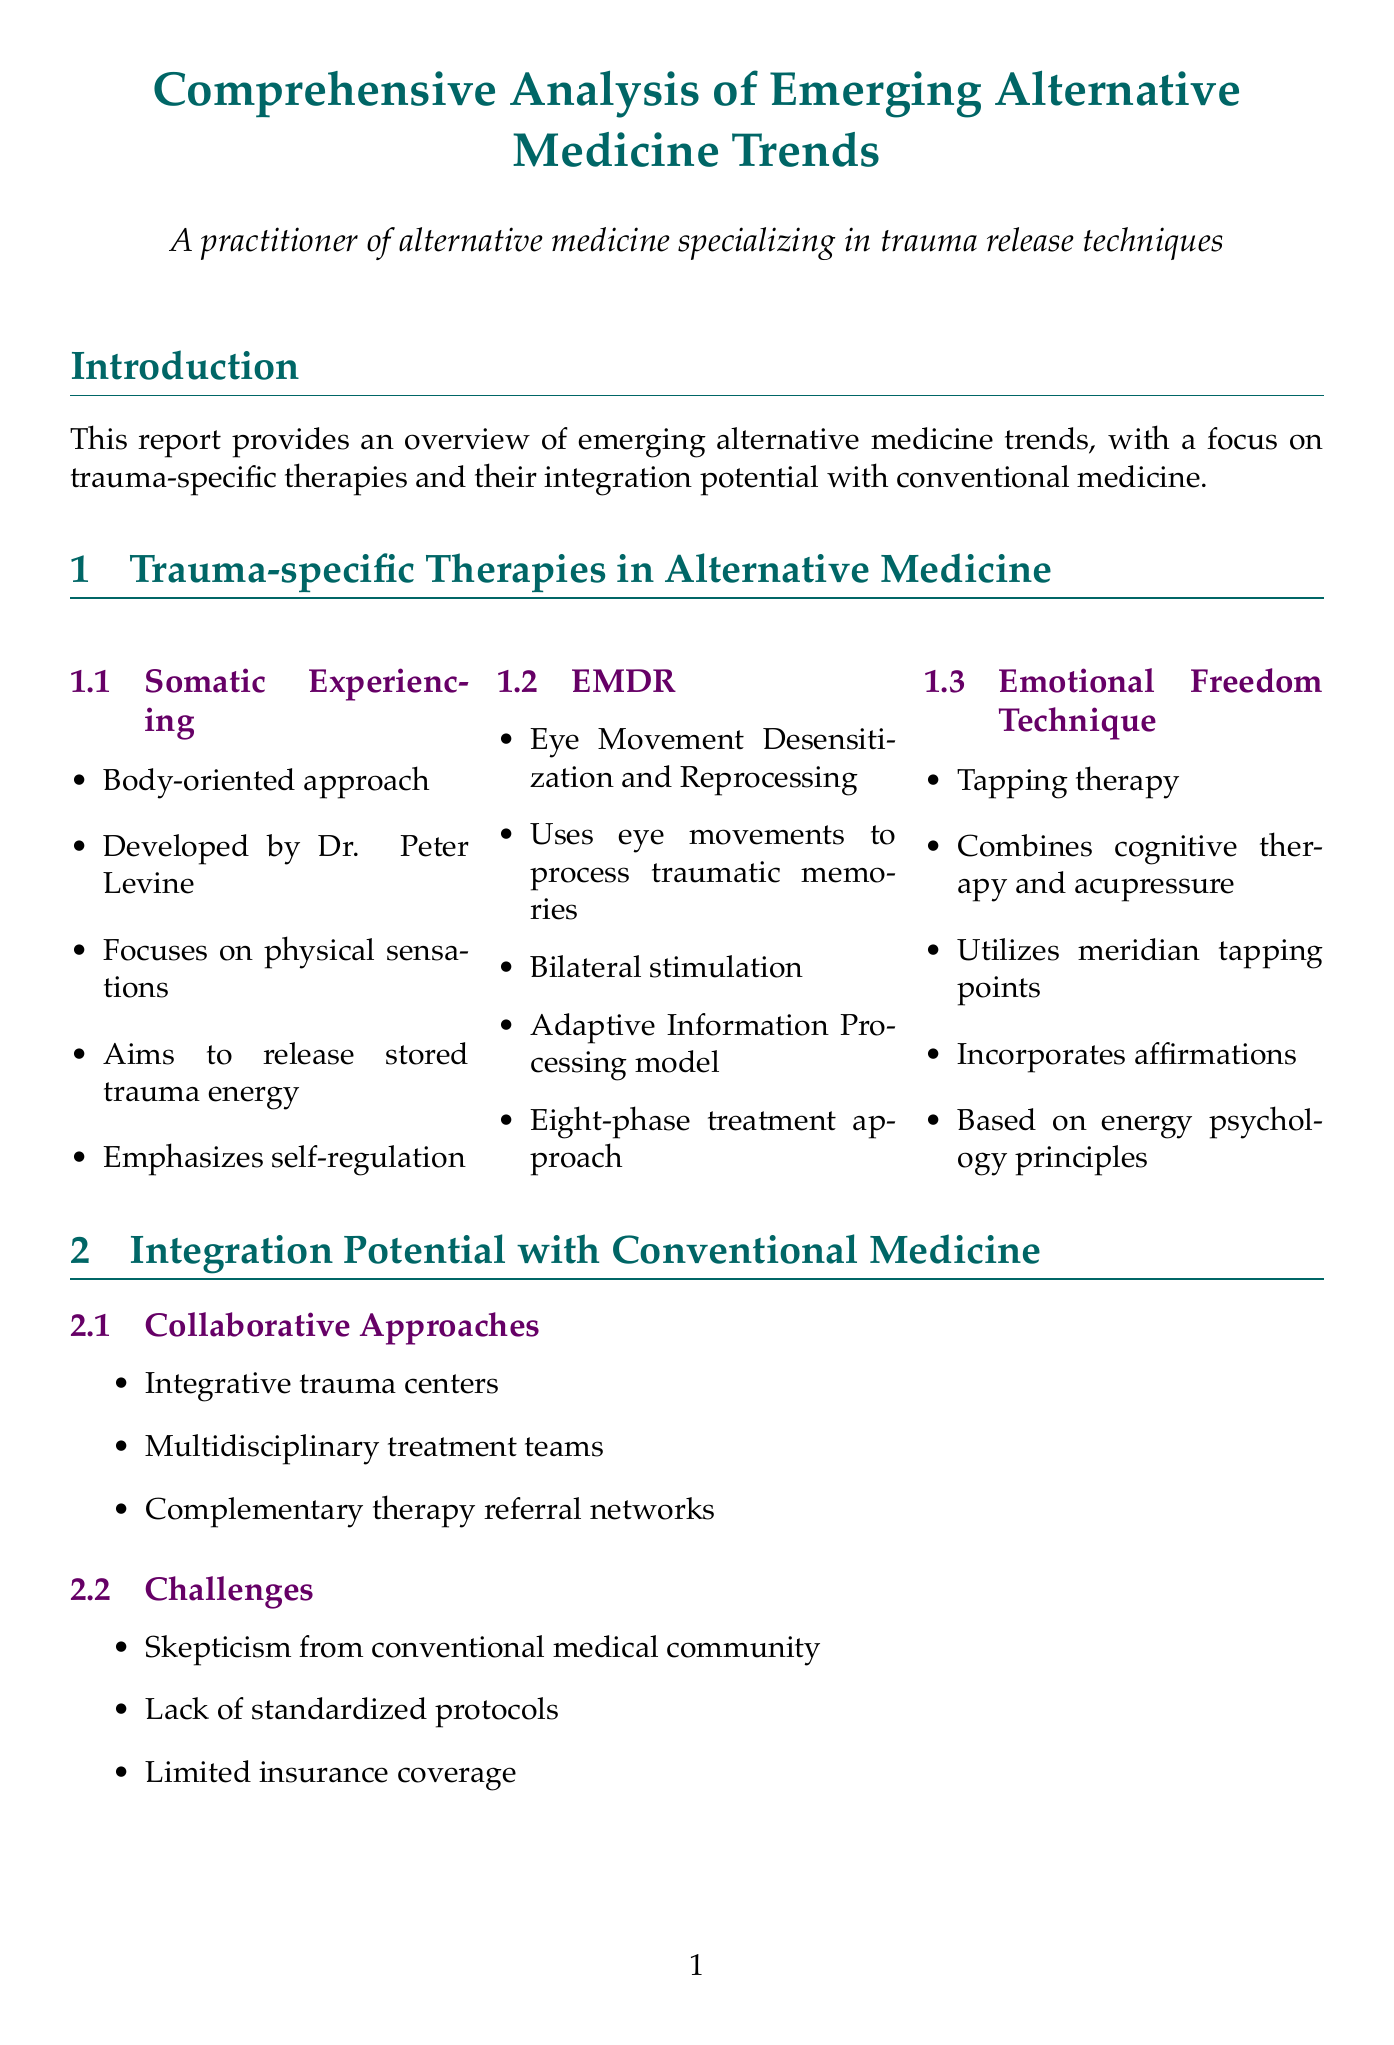What is the primary focus of the report? The primary focus of the report is on trauma-specific therapies and their integration potential with conventional medicine.
Answer: Trauma-specific therapies What therapy is developed by Dr. Peter Levine? The document mentions that Somatic Experiencing is developed by Dr. Peter Levine.
Answer: Somatic Experiencing What percentage of participants experienced reduced PTSD symptoms in the Somatic Experiencing study? The report states that 78% of participants had reduced PTSD symptoms.
Answer: 78% What are two key principles of EMDR? The document lists bilateral stimulation and the Adaptive Information Processing model as key principles of EMDR.
Answer: Bilateral stimulation, Adaptive Information Processing model What is one challenge of integrating alternative therapies with conventional medicine? The report mentions skepticism from the conventional medical community as one challenge.
Answer: Skepticism Which institution conducted the EMDR study for childhood trauma survivors? According to the report, the University of California, Los Angeles conducted the EMDR study.
Answer: University of California, Los Angeles What is one research direction mentioned for future trauma-focused therapies? Personalized trauma treatment algorithms are mentioned as a future research direction.
Answer: Personalized trauma treatment algorithms What is the main outcome of the meta-analysis of alternative trauma therapies? The report states that the meta-analysis found comparable efficacy to cognitive-behavioral therapy.
Answer: Comparable efficacy to cognitive-behavioral therapy What emerging modality is focused on trauma processing? The document includes neurofeedback as an emerging modality for trauma processing.
Answer: Neurofeedback 